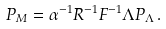<formula> <loc_0><loc_0><loc_500><loc_500>P _ { M } = \alpha ^ { - 1 } R ^ { - 1 } F ^ { - 1 } \Lambda P _ { \Lambda } \, .</formula> 